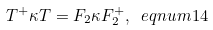Convert formula to latex. <formula><loc_0><loc_0><loc_500><loc_500>T ^ { + } \kappa T = F _ { 2 } \kappa F _ { 2 } ^ { + } , \ e q n u m { 1 4 }</formula> 